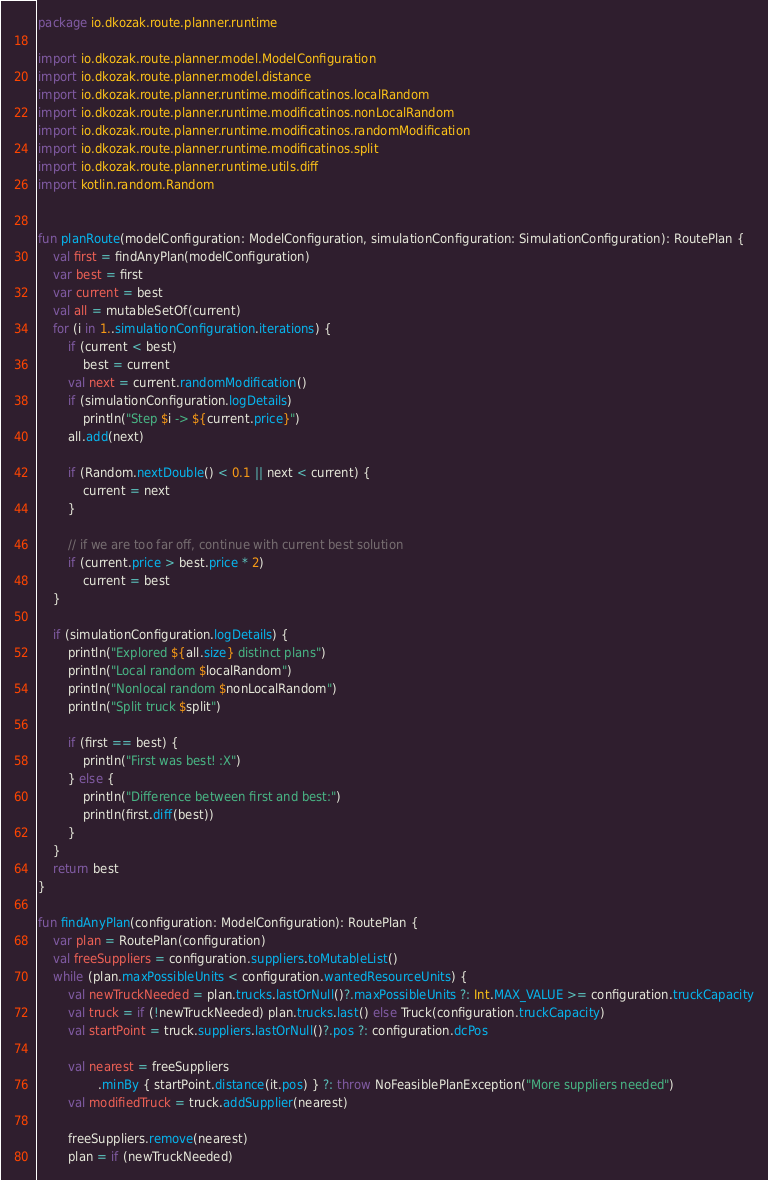<code> <loc_0><loc_0><loc_500><loc_500><_Kotlin_>package io.dkozak.route.planner.runtime

import io.dkozak.route.planner.model.ModelConfiguration
import io.dkozak.route.planner.model.distance
import io.dkozak.route.planner.runtime.modificatinos.localRandom
import io.dkozak.route.planner.runtime.modificatinos.nonLocalRandom
import io.dkozak.route.planner.runtime.modificatinos.randomModification
import io.dkozak.route.planner.runtime.modificatinos.split
import io.dkozak.route.planner.runtime.utils.diff
import kotlin.random.Random


fun planRoute(modelConfiguration: ModelConfiguration, simulationConfiguration: SimulationConfiguration): RoutePlan {
    val first = findAnyPlan(modelConfiguration)
    var best = first
    var current = best
    val all = mutableSetOf(current)
    for (i in 1..simulationConfiguration.iterations) {
        if (current < best)
            best = current
        val next = current.randomModification()
        if (simulationConfiguration.logDetails)
            println("Step $i -> ${current.price}")
        all.add(next)

        if (Random.nextDouble() < 0.1 || next < current) {
            current = next
        }

        // if we are too far off, continue with current best solution
        if (current.price > best.price * 2)
            current = best
    }

    if (simulationConfiguration.logDetails) {
        println("Explored ${all.size} distinct plans")
        println("Local random $localRandom")
        println("Nonlocal random $nonLocalRandom")
        println("Split truck $split")

        if (first == best) {
            println("First was best! :X")
        } else {
            println("Difference between first and best:")
            println(first.diff(best))
        }
    }
    return best
}

fun findAnyPlan(configuration: ModelConfiguration): RoutePlan {
    var plan = RoutePlan(configuration)
    val freeSuppliers = configuration.suppliers.toMutableList()
    while (plan.maxPossibleUnits < configuration.wantedResourceUnits) {
        val newTruckNeeded = plan.trucks.lastOrNull()?.maxPossibleUnits ?: Int.MAX_VALUE >= configuration.truckCapacity
        val truck = if (!newTruckNeeded) plan.trucks.last() else Truck(configuration.truckCapacity)
        val startPoint = truck.suppliers.lastOrNull()?.pos ?: configuration.dcPos

        val nearest = freeSuppliers
                .minBy { startPoint.distance(it.pos) } ?: throw NoFeasiblePlanException("More suppliers needed")
        val modifiedTruck = truck.addSupplier(nearest)

        freeSuppliers.remove(nearest)
        plan = if (newTruckNeeded)</code> 